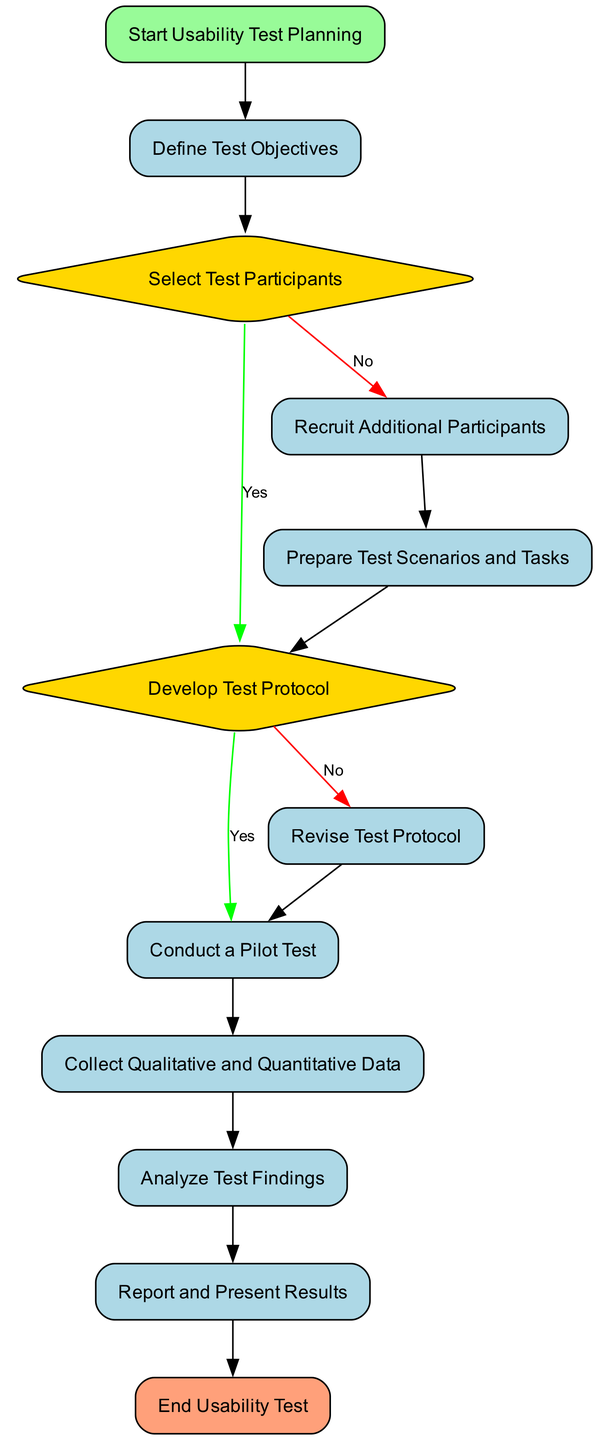What is the starting point of the usability test process? The starting point is the node labeled "Start Usability Test Planning," indicating where the process begins.
Answer: Start Usability Test Planning How many decision points are there in the diagram? The decision points are identified by the "Decision" type nodes: "Select Test Participants" and "Develop Test Protocol." Therefore, there are 2 decision points.
Answer: 2 What happens if selected participants do not match the target user persona? If the selected participants do not match the target user persona, the process directs to the node labeled "Recruit Additional Participants," indicating that additional recruitment is needed.
Answer: Recruit Additional Participants What is the next step after successfully developing the test protocol? After a comprehensive and clear test protocol is developed, the next step is to "Conduct a Pilot Test," as indicated by the flow from the decision node to this process node.
Answer: Conduct a Pilot Test What type of data should be collected during the usability test? The test should gather both "Qualitative and Quantitative Data" to understand user behavior, according to the designated node in the flow chart.
Answer: Qualitative and Quantitative Data If the test protocol is not clear, what action should be taken? The action to be taken is to "Revise Test Protocol," as indicated in the flow chart, leading to enhancing and clarifying the protocol details.
Answer: Revise Test Protocol What is the final step of the usability test process? The final step is labeled "End Usability Test," marking the conclusion of the usability test process.
Answer: End Usability Test How many total nodes are present in the diagram? Counting all the nodes from start to end, including decision points and processes, the total is 12 nodes in the diagram.
Answer: 12 What kind of recommendations should be included in the report? The report should include "actionable recommendations," as stated in the process for reporting and presenting results in the diagram.
Answer: Actionable recommendations 